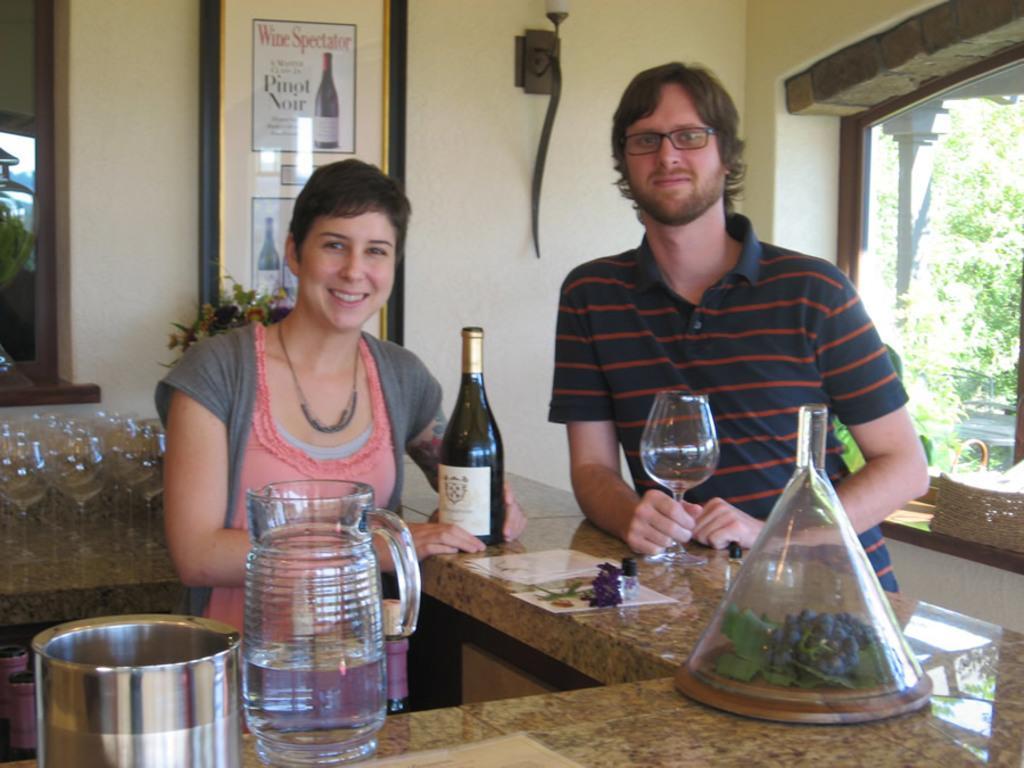Can you describe this image briefly? As we can see in the image there is a wall, photo frame, window, two people standing over here and ramp. On ramp there are glasses, bottle, bowl and outside the window there are trees. 